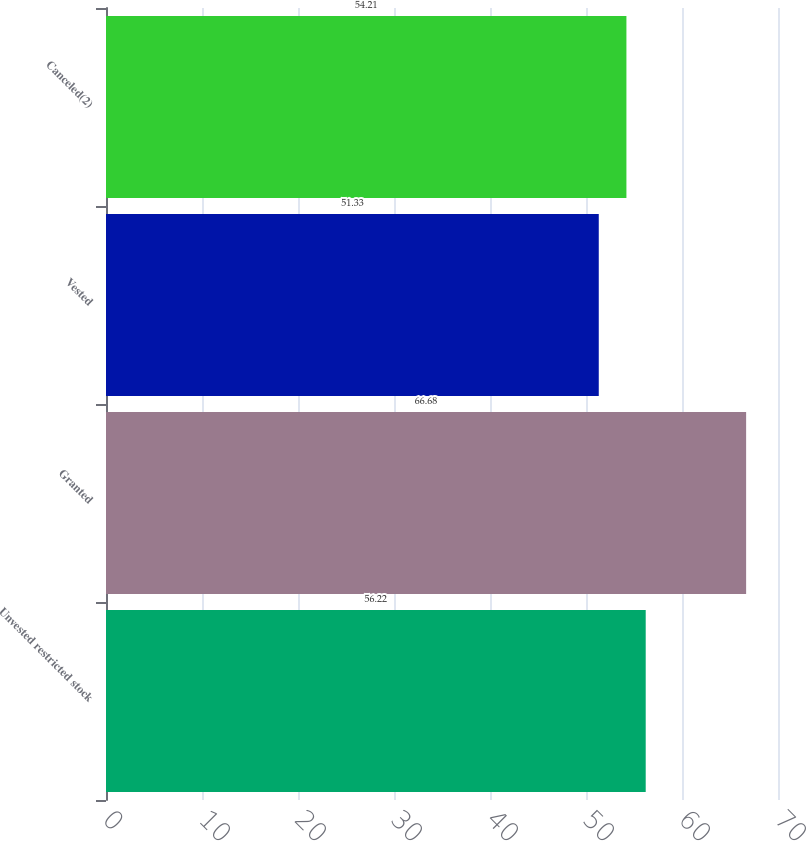Convert chart to OTSL. <chart><loc_0><loc_0><loc_500><loc_500><bar_chart><fcel>Unvested restricted stock<fcel>Granted<fcel>Vested<fcel>Canceled(2)<nl><fcel>56.22<fcel>66.68<fcel>51.33<fcel>54.21<nl></chart> 